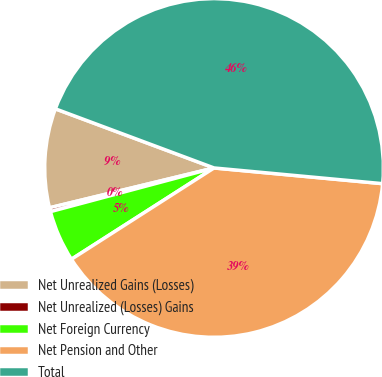<chart> <loc_0><loc_0><loc_500><loc_500><pie_chart><fcel>Net Unrealized Gains (Losses)<fcel>Net Unrealized (Losses) Gains<fcel>Net Foreign Currency<fcel>Net Pension and Other<fcel>Total<nl><fcel>9.46%<fcel>0.37%<fcel>4.91%<fcel>39.46%<fcel>45.8%<nl></chart> 